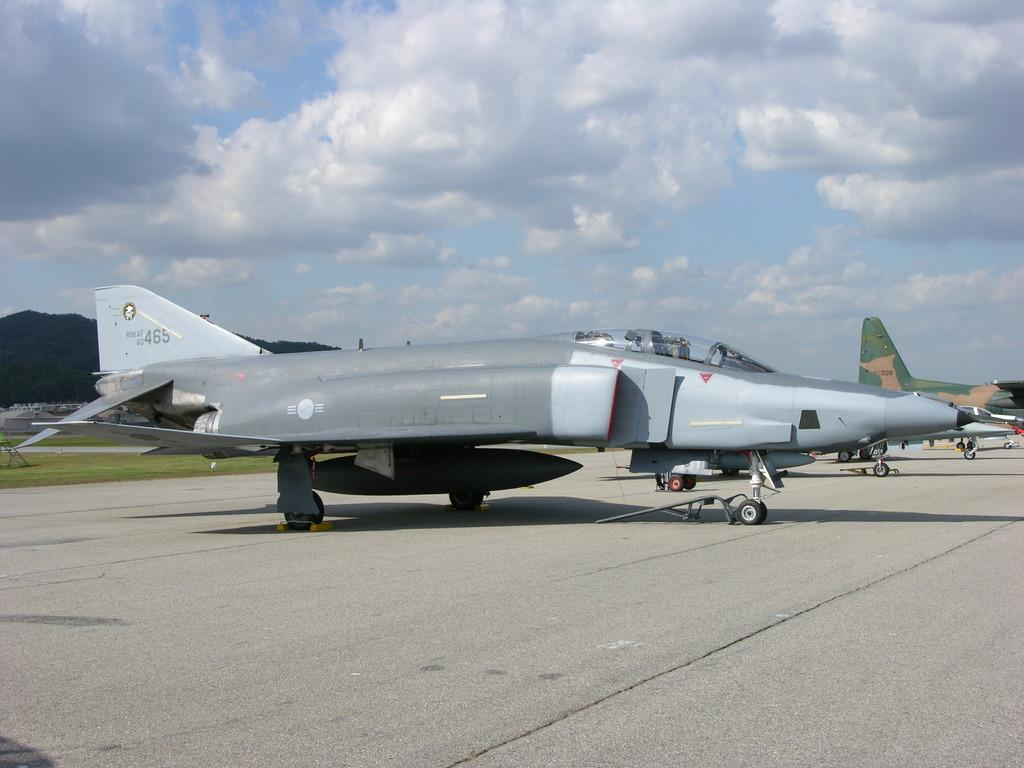What is the main subject of the image? The main subject of the image is aircraft. What else can be observed in the image besides the aircraft? Shadows, numbers, and the sky are visible in the image. Can you describe the background of the image? The sky is visible in the background of the image, and clouds are present. What type of crack can be seen in the image? There is no crack present in the image. What structure is responsible for the decision-making process in the image? The image does not depict any decision-making process or structure. 